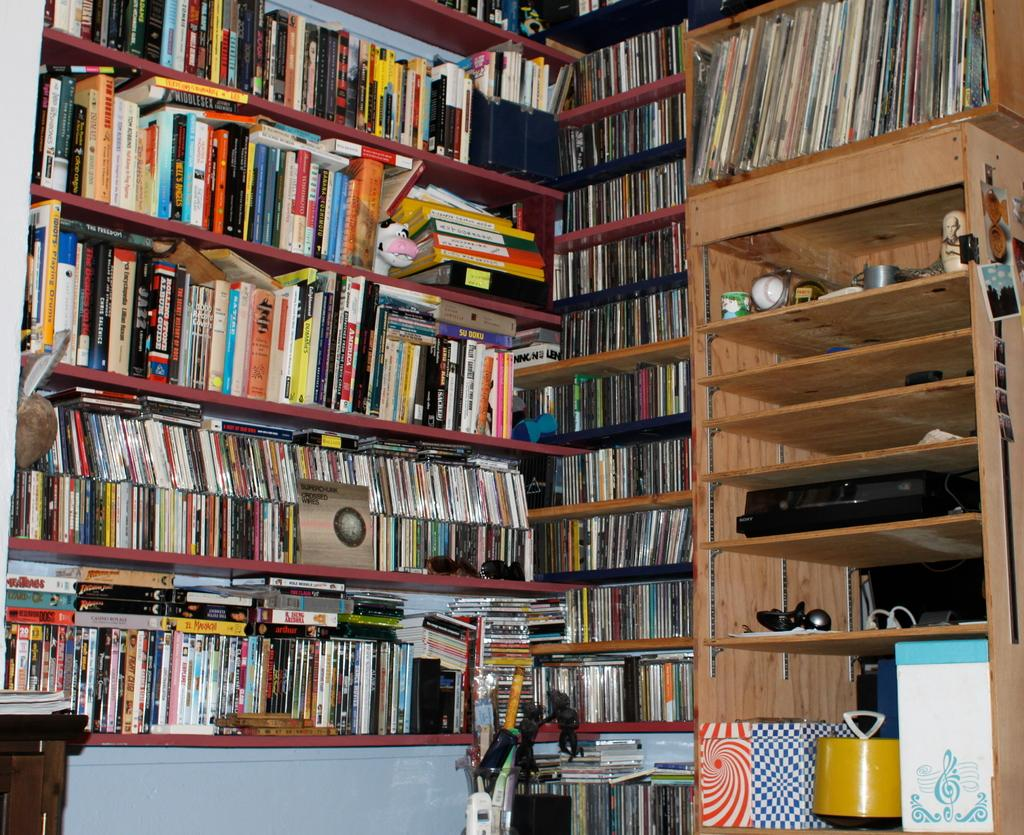What is the main object in the image? There is a cupboard with many books in the image. Can you describe the other cupboard in the image? There is a cupboard with a clock and other items on the left side of the image. What color is the partner's body in the image? There is no partner or body present in the image; it only features two cupboards. 